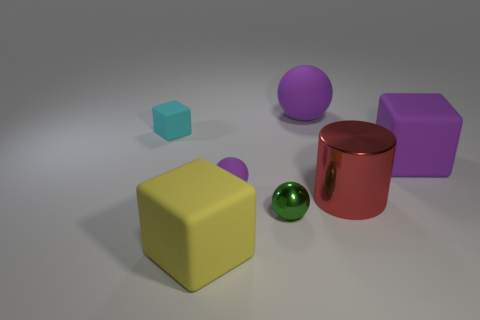Add 3 metal objects. How many objects exist? 10 Subtract all spheres. How many objects are left? 4 Subtract all purple rubber balls. Subtract all big purple things. How many objects are left? 3 Add 4 large red metallic cylinders. How many large red metallic cylinders are left? 5 Add 7 brown shiny spheres. How many brown shiny spheres exist? 7 Subtract 0 brown cylinders. How many objects are left? 7 